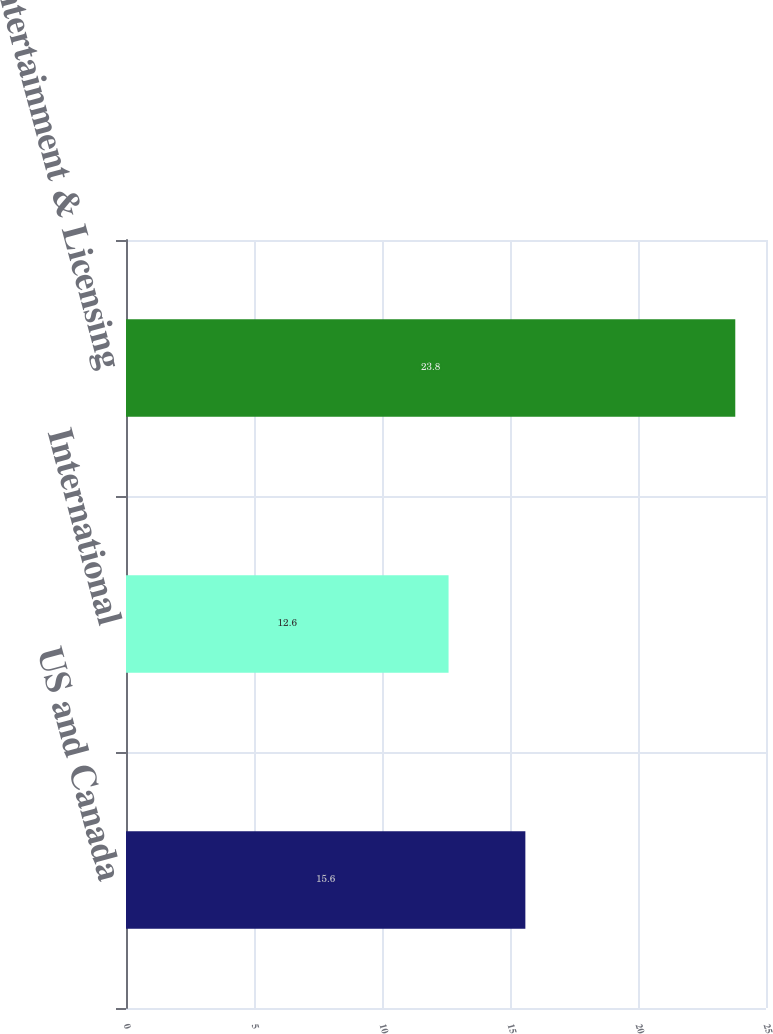Convert chart to OTSL. <chart><loc_0><loc_0><loc_500><loc_500><bar_chart><fcel>US and Canada<fcel>International<fcel>Entertainment & Licensing<nl><fcel>15.6<fcel>12.6<fcel>23.8<nl></chart> 